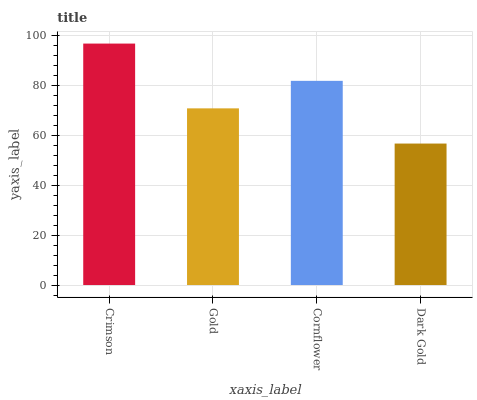Is Dark Gold the minimum?
Answer yes or no. Yes. Is Crimson the maximum?
Answer yes or no. Yes. Is Gold the minimum?
Answer yes or no. No. Is Gold the maximum?
Answer yes or no. No. Is Crimson greater than Gold?
Answer yes or no. Yes. Is Gold less than Crimson?
Answer yes or no. Yes. Is Gold greater than Crimson?
Answer yes or no. No. Is Crimson less than Gold?
Answer yes or no. No. Is Cornflower the high median?
Answer yes or no. Yes. Is Gold the low median?
Answer yes or no. Yes. Is Dark Gold the high median?
Answer yes or no. No. Is Cornflower the low median?
Answer yes or no. No. 